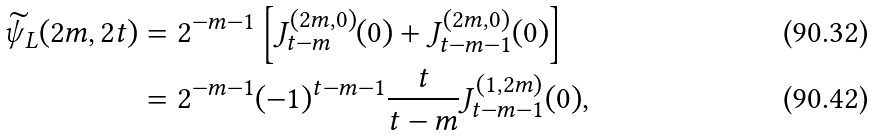<formula> <loc_0><loc_0><loc_500><loc_500>\widetilde { \psi } _ { L } ( 2 m , 2 t ) & = 2 ^ { - m - 1 } \left [ J _ { t - m } ^ { ( 2 m , 0 ) } ( 0 ) + J _ { t - m - 1 } ^ { ( 2 m , 0 ) } ( 0 ) \right ] \\ & = 2 ^ { - m - 1 } ( - 1 ) ^ { t - m - 1 } \frac { t } { t - m } J _ { t - m - 1 } ^ { ( 1 , 2 m ) } ( 0 ) ,</formula> 